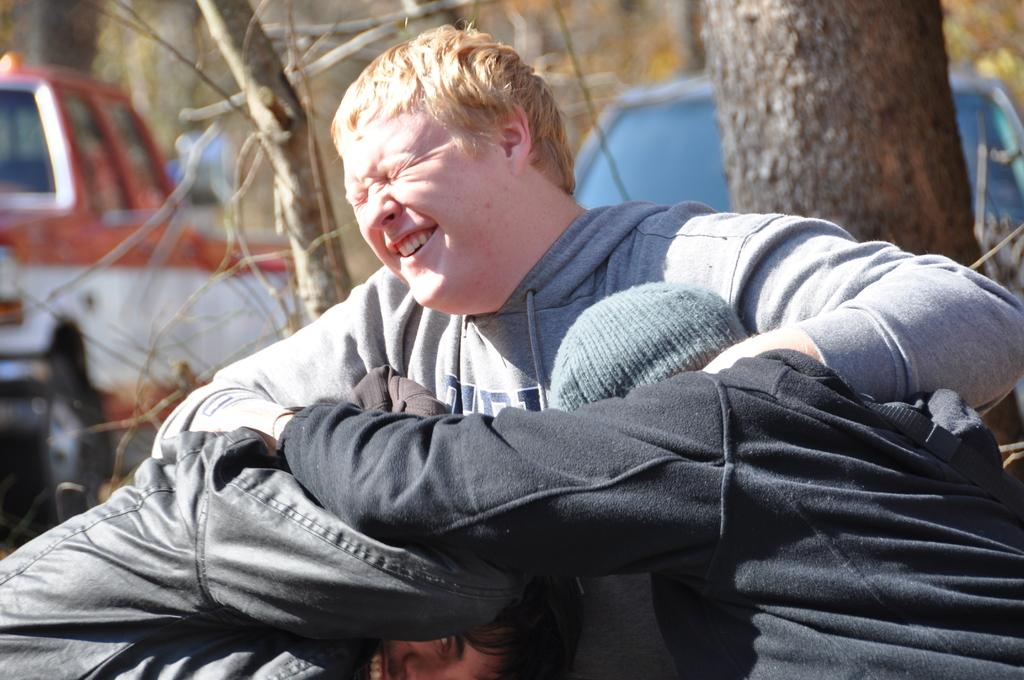How many people are in the image? There are three persons in the image. What are the three persons doing? The three persons are holding each other. What expressions do two of the persons have? Two of the persons are smiling. What can be seen in the background of the image? There are vehicles and trees in the background of the image. Can you see any fairies flying around the persons in the image? No, there are no fairies present in the image. Does the existence of the persons in the image prove the existence of life on other planets? No, the existence of the persons in the image does not prove the existence of life on other planets. 